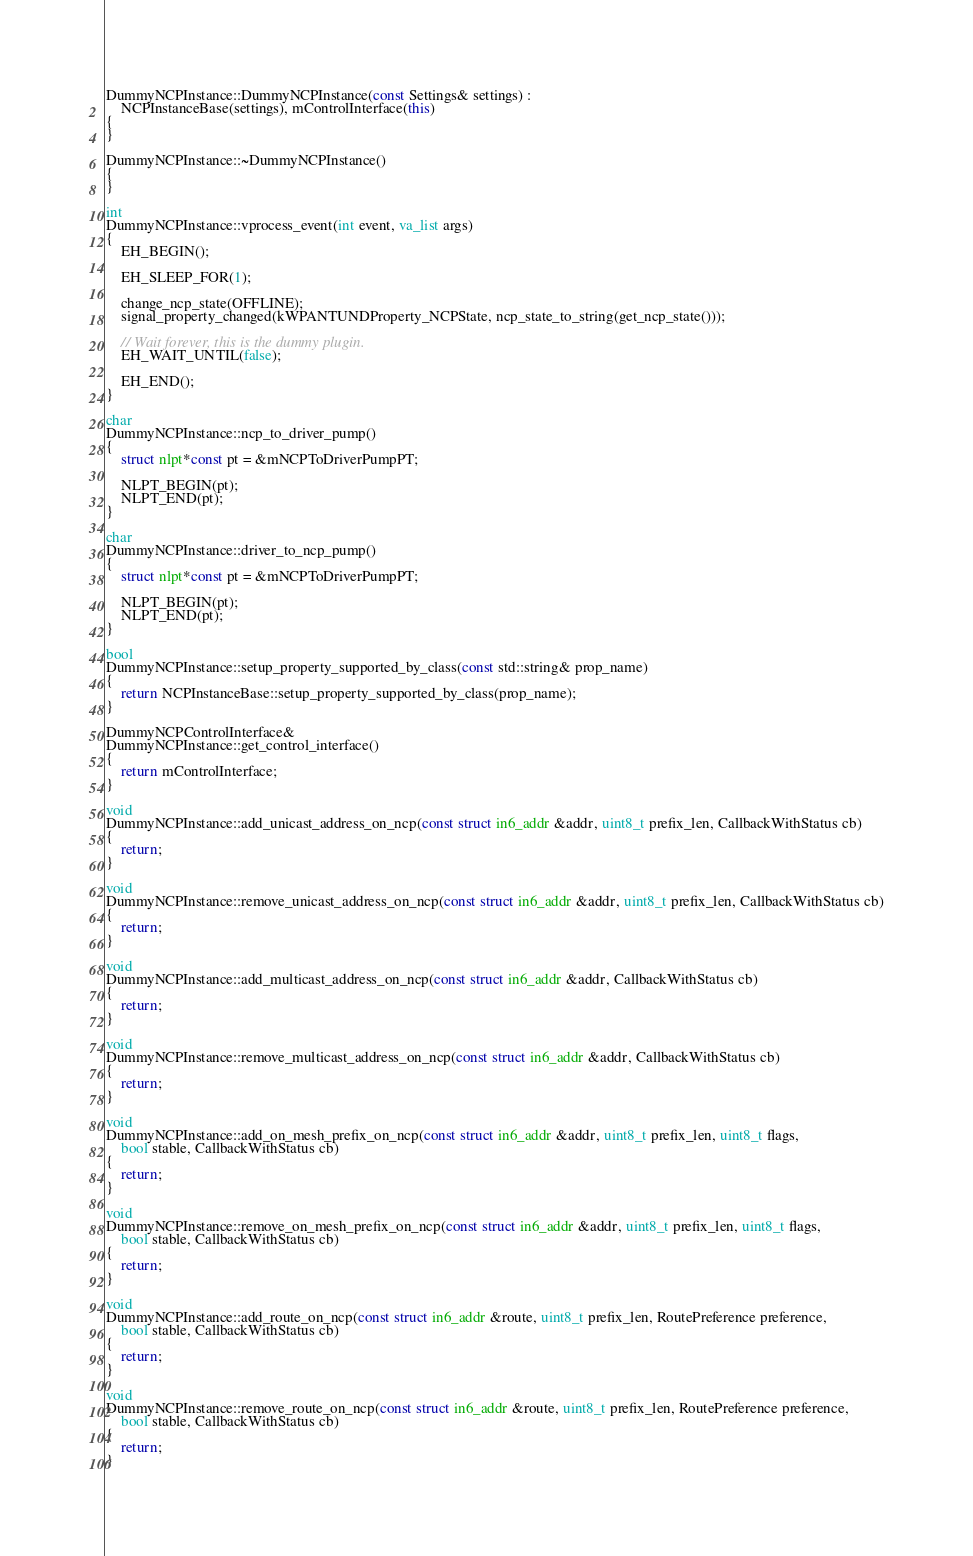Convert code to text. <code><loc_0><loc_0><loc_500><loc_500><_C++_>
DummyNCPInstance::DummyNCPInstance(const Settings& settings) :
	NCPInstanceBase(settings), mControlInterface(this)
{
}

DummyNCPInstance::~DummyNCPInstance()
{
}

int
DummyNCPInstance::vprocess_event(int event, va_list args)
{
	EH_BEGIN();

	EH_SLEEP_FOR(1);

	change_ncp_state(OFFLINE);
	signal_property_changed(kWPANTUNDProperty_NCPState, ncp_state_to_string(get_ncp_state()));

	// Wait forever, this is the dummy plugin.
	EH_WAIT_UNTIL(false);

	EH_END();
}

char
DummyNCPInstance::ncp_to_driver_pump()
{
	struct nlpt*const pt = &mNCPToDriverPumpPT;

	NLPT_BEGIN(pt);
	NLPT_END(pt);
}

char
DummyNCPInstance::driver_to_ncp_pump()
{
	struct nlpt*const pt = &mNCPToDriverPumpPT;

	NLPT_BEGIN(pt);
	NLPT_END(pt);
}

bool
DummyNCPInstance::setup_property_supported_by_class(const std::string& prop_name)
{
	return NCPInstanceBase::setup_property_supported_by_class(prop_name);
}

DummyNCPControlInterface&
DummyNCPInstance::get_control_interface()
{
	return mControlInterface;
}

void
DummyNCPInstance::add_unicast_address_on_ncp(const struct in6_addr &addr, uint8_t prefix_len, CallbackWithStatus cb)
{
	return;
}

void
DummyNCPInstance::remove_unicast_address_on_ncp(const struct in6_addr &addr, uint8_t prefix_len, CallbackWithStatus cb)
{
	return;
}

void
DummyNCPInstance::add_multicast_address_on_ncp(const struct in6_addr &addr, CallbackWithStatus cb)
{
	return;
}

void
DummyNCPInstance::remove_multicast_address_on_ncp(const struct in6_addr &addr, CallbackWithStatus cb)
{
	return;
}

void
DummyNCPInstance::add_on_mesh_prefix_on_ncp(const struct in6_addr &addr, uint8_t prefix_len, uint8_t flags,
	bool stable, CallbackWithStatus cb)
{
	return;
}

void
DummyNCPInstance::remove_on_mesh_prefix_on_ncp(const struct in6_addr &addr, uint8_t prefix_len, uint8_t flags,
	bool stable, CallbackWithStatus cb)
{
	return;
}

void
DummyNCPInstance::add_route_on_ncp(const struct in6_addr &route, uint8_t prefix_len, RoutePreference preference,
	bool stable, CallbackWithStatus cb)
{
	return;
}

void
DummyNCPInstance::remove_route_on_ncp(const struct in6_addr &route, uint8_t prefix_len, RoutePreference preference,
	bool stable, CallbackWithStatus cb)
{
	return;
}
</code> 